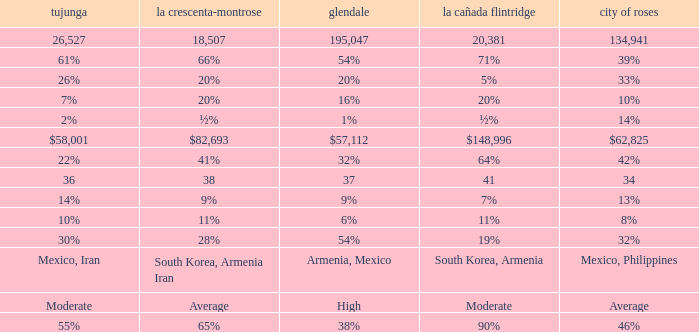What is the figure for La Crescenta-Montrose when Gelndale is $57,112? $82,693. 